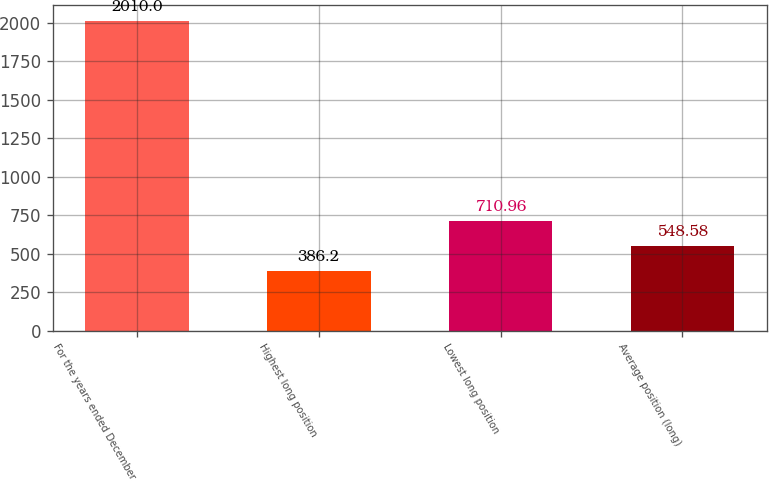Convert chart. <chart><loc_0><loc_0><loc_500><loc_500><bar_chart><fcel>For the years ended December<fcel>Highest long position<fcel>Lowest long position<fcel>Average position (long)<nl><fcel>2010<fcel>386.2<fcel>710.96<fcel>548.58<nl></chart> 